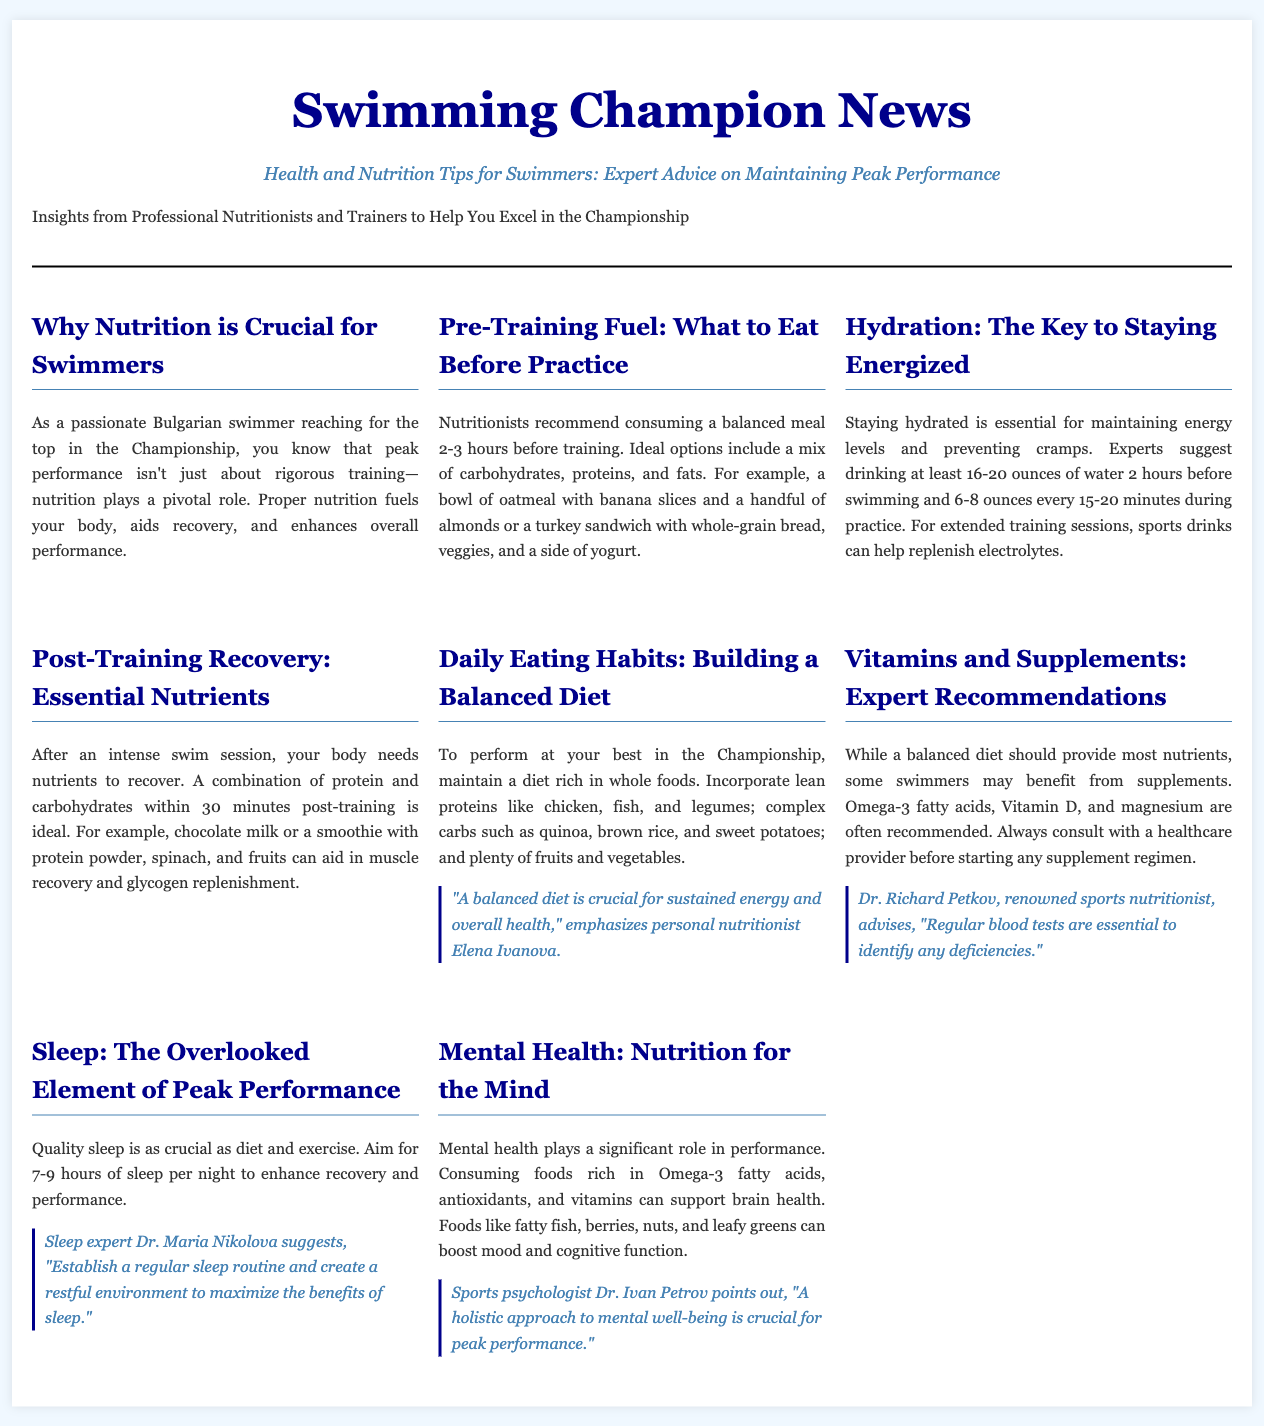Why is nutrition crucial for swimmers? The document states that nutrition plays a pivotal role in peak performance by fueling the body, aiding recovery, and enhancing overall performance.
Answer: Fueling the body, aiding recovery, enhancing overall performance What should swimmers eat before practice? The document recommends a balanced meal that includes carbohydrates, proteins, and fats, such as oatmeal with banana or a turkey sandwich.
Answer: Oatmeal with banana or a turkey sandwich How much water should be consumed 2 hours before swimming? According to the document, experts suggest drinking at least 16-20 ounces of water 2 hours before swimming.
Answer: 16-20 ounces What combination of nutrients is ideal post-training? After training, the ideal combination of nutrients is protein and carbohydrates within 30 minutes.
Answer: Protein and carbohydrates What type of diet is recommended for swimmers? The document recommends a diet rich in whole foods, including lean proteins, complex carbs, and plenty of fruits and vegetables.
Answer: Whole foods, lean proteins, complex carbs Which vitamins and supplements may be beneficial for swimmers? The document mentions Omega-3 fatty acids, Vitamin D, and magnesium as beneficial supplements.
Answer: Omega-3 fatty acids, Vitamin D, magnesium How many hours of sleep should swimmers aim for? Swimmers are advised to aim for 7-9 hours of sleep per night for enhanced recovery and performance.
Answer: 7-9 hours What element of performance is often overlooked? The document points out that quality sleep is often an overlooked element of peak performance.
Answer: Quality sleep 